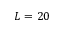<formula> <loc_0><loc_0><loc_500><loc_500>L = 2 0</formula> 